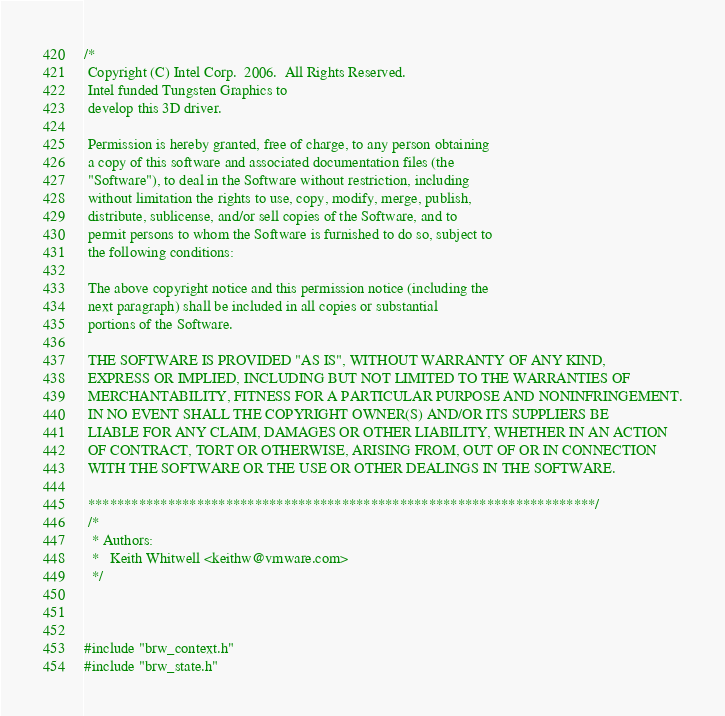Convert code to text. <code><loc_0><loc_0><loc_500><loc_500><_C_>/*
 Copyright (C) Intel Corp.  2006.  All Rights Reserved.
 Intel funded Tungsten Graphics to
 develop this 3D driver.

 Permission is hereby granted, free of charge, to any person obtaining
 a copy of this software and associated documentation files (the
 "Software"), to deal in the Software without restriction, including
 without limitation the rights to use, copy, modify, merge, publish,
 distribute, sublicense, and/or sell copies of the Software, and to
 permit persons to whom the Software is furnished to do so, subject to
 the following conditions:

 The above copyright notice and this permission notice (including the
 next paragraph) shall be included in all copies or substantial
 portions of the Software.

 THE SOFTWARE IS PROVIDED "AS IS", WITHOUT WARRANTY OF ANY KIND,
 EXPRESS OR IMPLIED, INCLUDING BUT NOT LIMITED TO THE WARRANTIES OF
 MERCHANTABILITY, FITNESS FOR A PARTICULAR PURPOSE AND NONINFRINGEMENT.
 IN NO EVENT SHALL THE COPYRIGHT OWNER(S) AND/OR ITS SUPPLIERS BE
 LIABLE FOR ANY CLAIM, DAMAGES OR OTHER LIABILITY, WHETHER IN AN ACTION
 OF CONTRACT, TORT OR OTHERWISE, ARISING FROM, OUT OF OR IN CONNECTION
 WITH THE SOFTWARE OR THE USE OR OTHER DEALINGS IN THE SOFTWARE.

 **********************************************************************/
 /*
  * Authors:
  *   Keith Whitwell <keithw@vmware.com>
  */



#include "brw_context.h"
#include "brw_state.h"</code> 